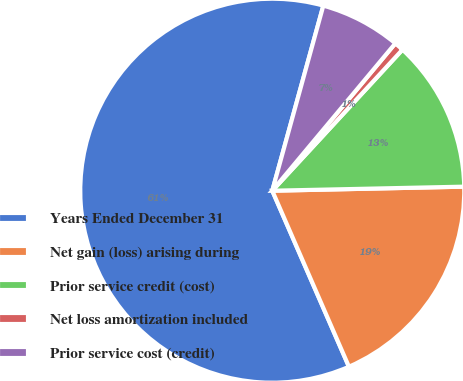<chart> <loc_0><loc_0><loc_500><loc_500><pie_chart><fcel>Years Ended December 31<fcel>Net gain (loss) arising during<fcel>Prior service credit (cost)<fcel>Net loss amortization included<fcel>Prior service cost (credit)<nl><fcel>60.83%<fcel>18.8%<fcel>12.8%<fcel>0.79%<fcel>6.79%<nl></chart> 